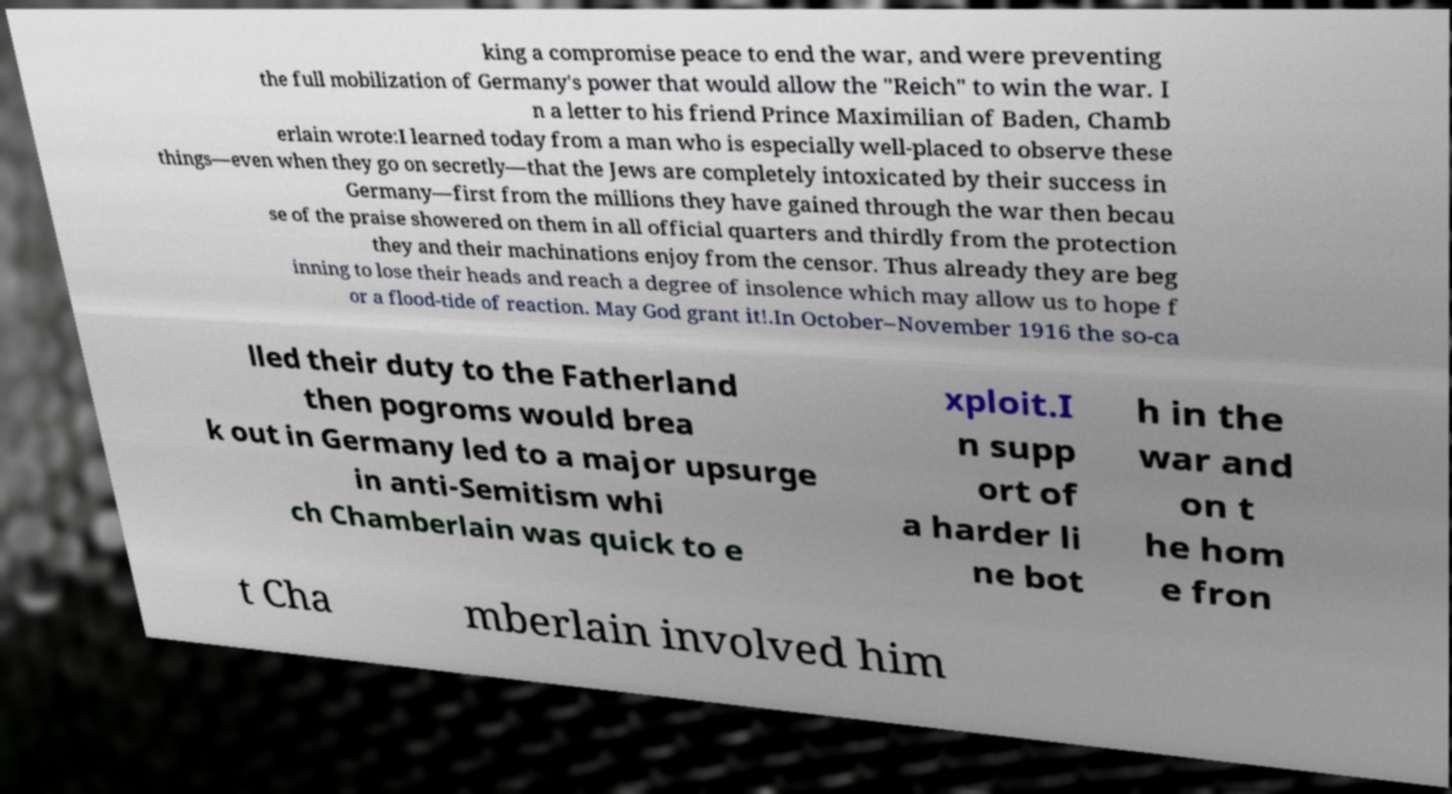For documentation purposes, I need the text within this image transcribed. Could you provide that? king a compromise peace to end the war, and were preventing the full mobilization of Germany's power that would allow the "Reich" to win the war. I n a letter to his friend Prince Maximilian of Baden, Chamb erlain wrote:I learned today from a man who is especially well-placed to observe these things—even when they go on secretly—that the Jews are completely intoxicated by their success in Germany—first from the millions they have gained through the war then becau se of the praise showered on them in all official quarters and thirdly from the protection they and their machinations enjoy from the censor. Thus already they are beg inning to lose their heads and reach a degree of insolence which may allow us to hope f or a flood-tide of reaction. May God grant it!.In October–November 1916 the so-ca lled their duty to the Fatherland then pogroms would brea k out in Germany led to a major upsurge in anti-Semitism whi ch Chamberlain was quick to e xploit.I n supp ort of a harder li ne bot h in the war and on t he hom e fron t Cha mberlain involved him 